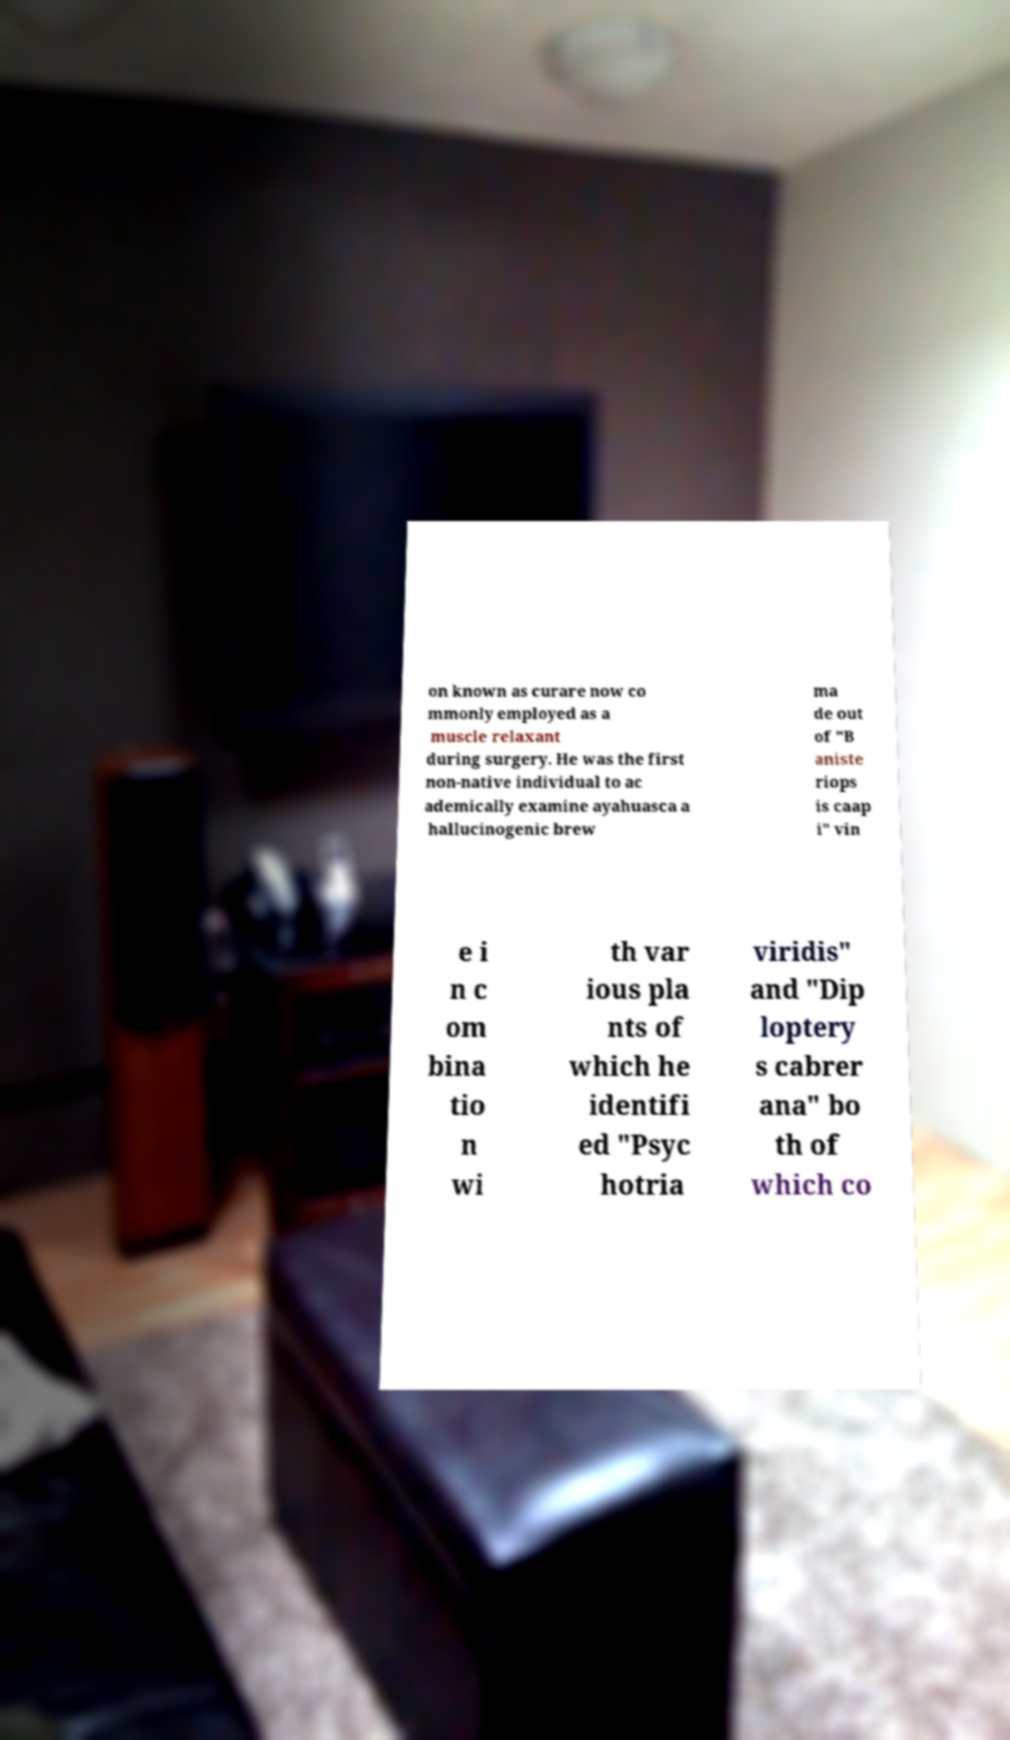There's text embedded in this image that I need extracted. Can you transcribe it verbatim? on known as curare now co mmonly employed as a muscle relaxant during surgery. He was the first non-native individual to ac ademically examine ayahuasca a hallucinogenic brew ma de out of "B aniste riops is caap i" vin e i n c om bina tio n wi th var ious pla nts of which he identifi ed "Psyc hotria viridis" and "Dip loptery s cabrer ana" bo th of which co 